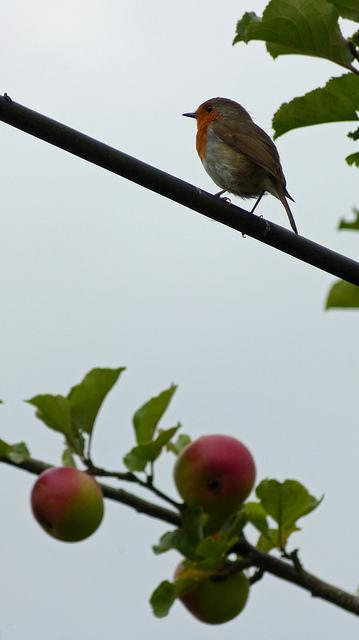How many birds are hanging upside down?

Choices:
A) four
B) none
C) three
D) two none 